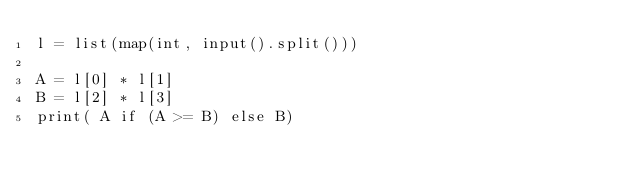Convert code to text. <code><loc_0><loc_0><loc_500><loc_500><_Python_>l = list(map(int, input().split()))

A = l[0] * l[1]
B = l[2] * l[3]
print( A if (A >= B) else B)</code> 